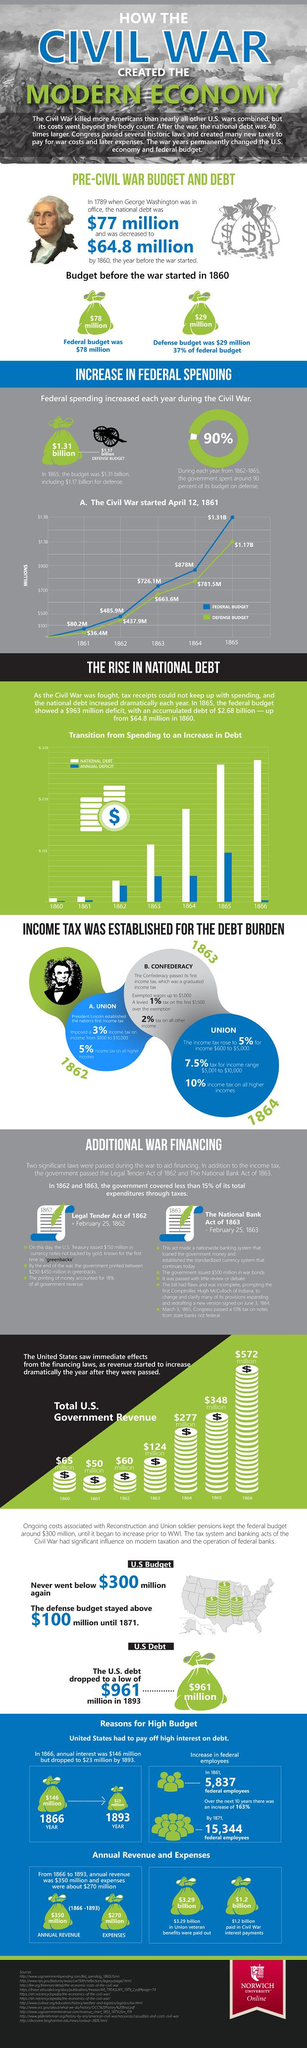Identify some key points in this picture. In 1864, the federal budget of the United States was $878 million. George Washington was the U.S. president in 1789. The American Civil War ended in 1865. In 1862, the defense budget of the United States was $437.9 million. During the Civil War, the defense budget reached its peak value in 1865. 